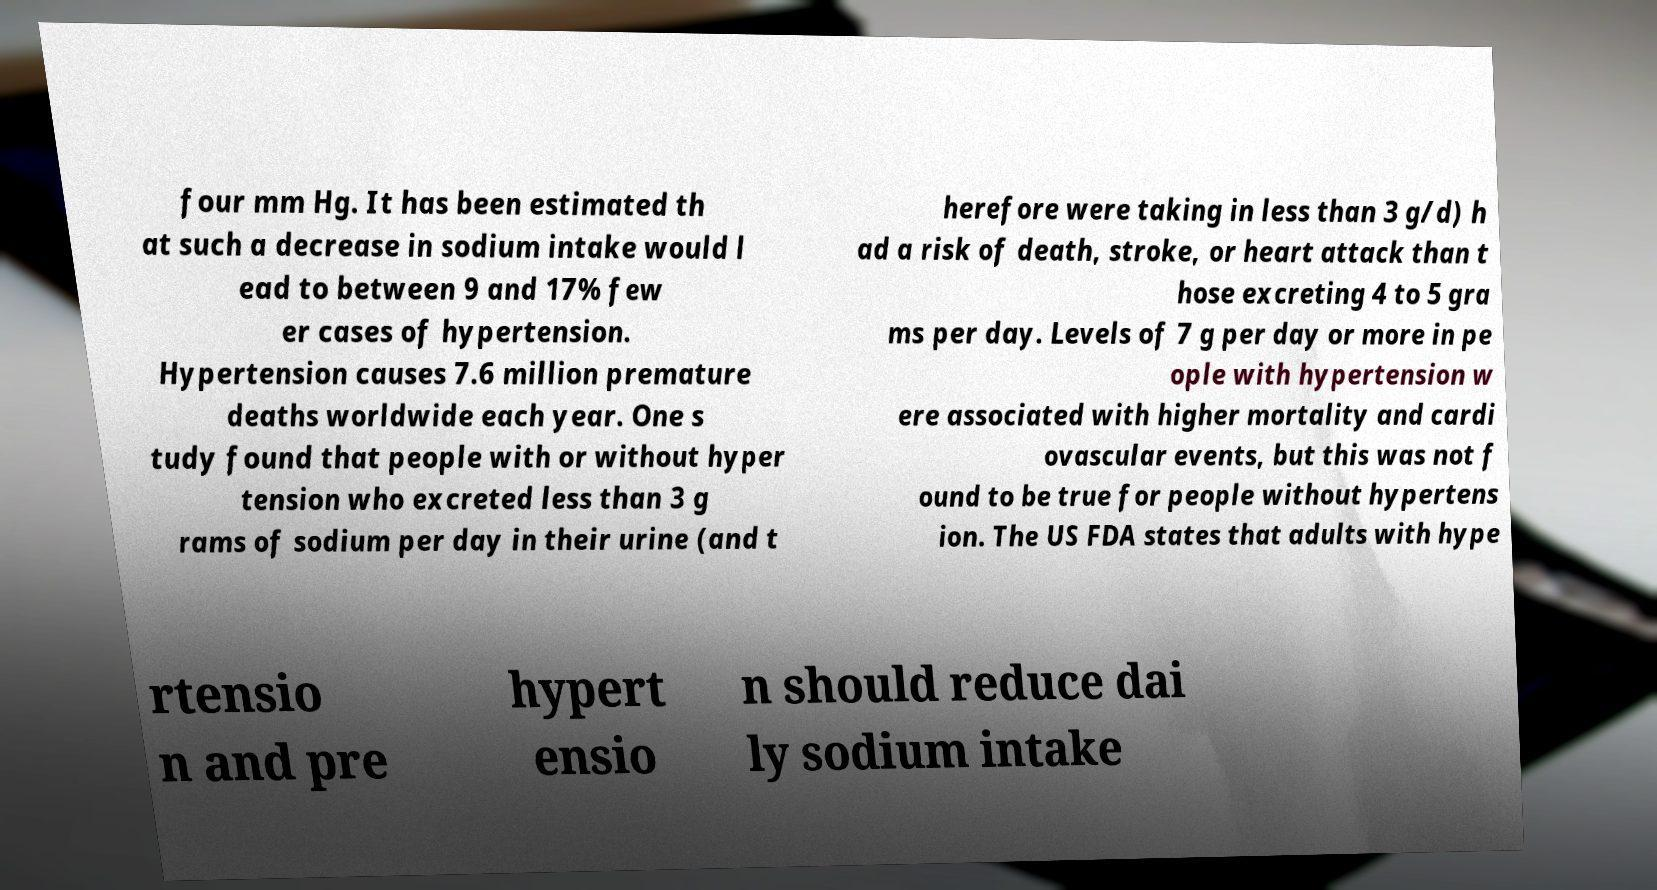Can you read and provide the text displayed in the image?This photo seems to have some interesting text. Can you extract and type it out for me? four mm Hg. It has been estimated th at such a decrease in sodium intake would l ead to between 9 and 17% few er cases of hypertension. Hypertension causes 7.6 million premature deaths worldwide each year. One s tudy found that people with or without hyper tension who excreted less than 3 g rams of sodium per day in their urine (and t herefore were taking in less than 3 g/d) h ad a risk of death, stroke, or heart attack than t hose excreting 4 to 5 gra ms per day. Levels of 7 g per day or more in pe ople with hypertension w ere associated with higher mortality and cardi ovascular events, but this was not f ound to be true for people without hypertens ion. The US FDA states that adults with hype rtensio n and pre hypert ensio n should reduce dai ly sodium intake 